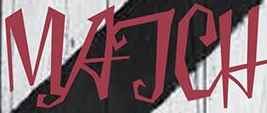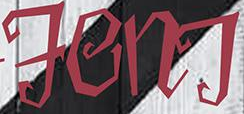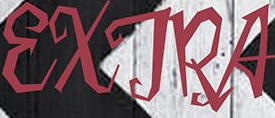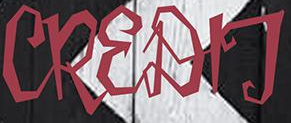Identify the words shown in these images in order, separated by a semicolon. MATCH; FenT; EXTRA; CREDIT 